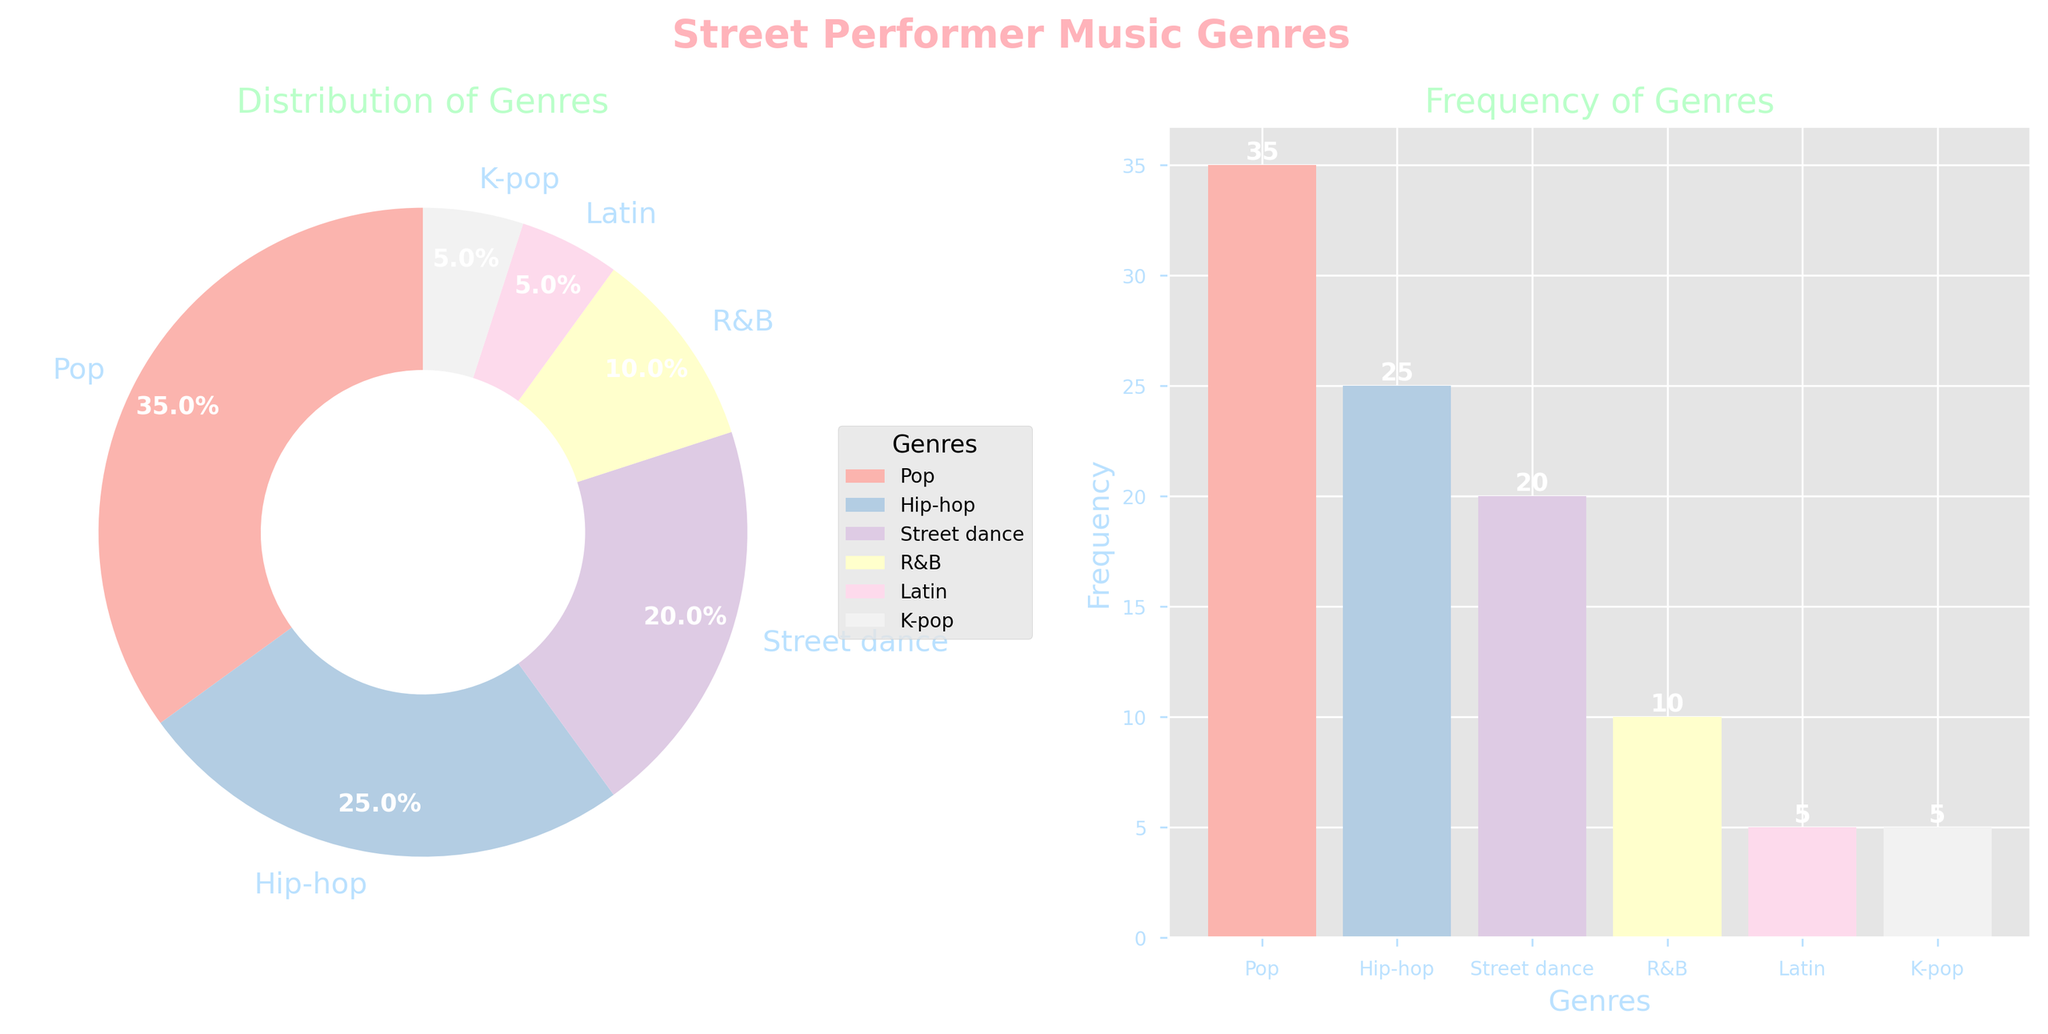What are the titles of the two subplots? The titles of the two subplots are "Distribution of Genres" and "Frequency of Genres". These titles are found above each respective subplot in the figure.
Answer: "Distribution of Genres" and "Frequency of Genres" How many music genres are displayed in the figure? There are 6 music genres displayed in the figure. This can be identified by counting the distinct sections in the pie chart or the number of bars in the bar chart.
Answer: 6 Which genre has the highest frequency? The genre with the highest frequency is Pop. This can be seen in both the pie chart, where Pop has the largest slice, and the bar chart, where Pop has the tallest bar.
Answer: Pop What percentage of the total does Street dance represent? Street dance represents 20% of the total. This is indicated directly on the pie chart as a percentage value for the Street dance slice.
Answer: 20% What is the combined percentage of Latin and K-pop? The combined percentage of Latin and K-pop is 10%. Adding their respective percentages from the pie chart (5% each) gives this total.
Answer: 10% How does the frequency of Hip-hop compare to that of R&B? The frequency of Hip-hop (25) is 15 more than that of R&B (10). This can be determined by observing the bar heights in the bar chart and the percentages in the pie chart.
Answer: 15 more Which genre appears least frequently? Latin and K-pop both appear the least frequently, each with a frequency of 5. This is seen in both the smallest slices in the pie chart and the shortest bars in the bar chart.
Answer: Latin and K-pop If you sum the frequencies of Hip-hop and Street dance, what value do you get? The sum of the frequencies of Hip-hop (25) and Street dance (20) is 45. This is calculated by adding their respective frequencies.
Answer: 45 What is the ratio of the frequency of Pop to the frequency of Latin? The ratio of the frequency of Pop (35) to the frequency of Latin (5) is 7:1. This is determined by dividing the frequency of Pop by the frequency of Latin.
Answer: 7:1 